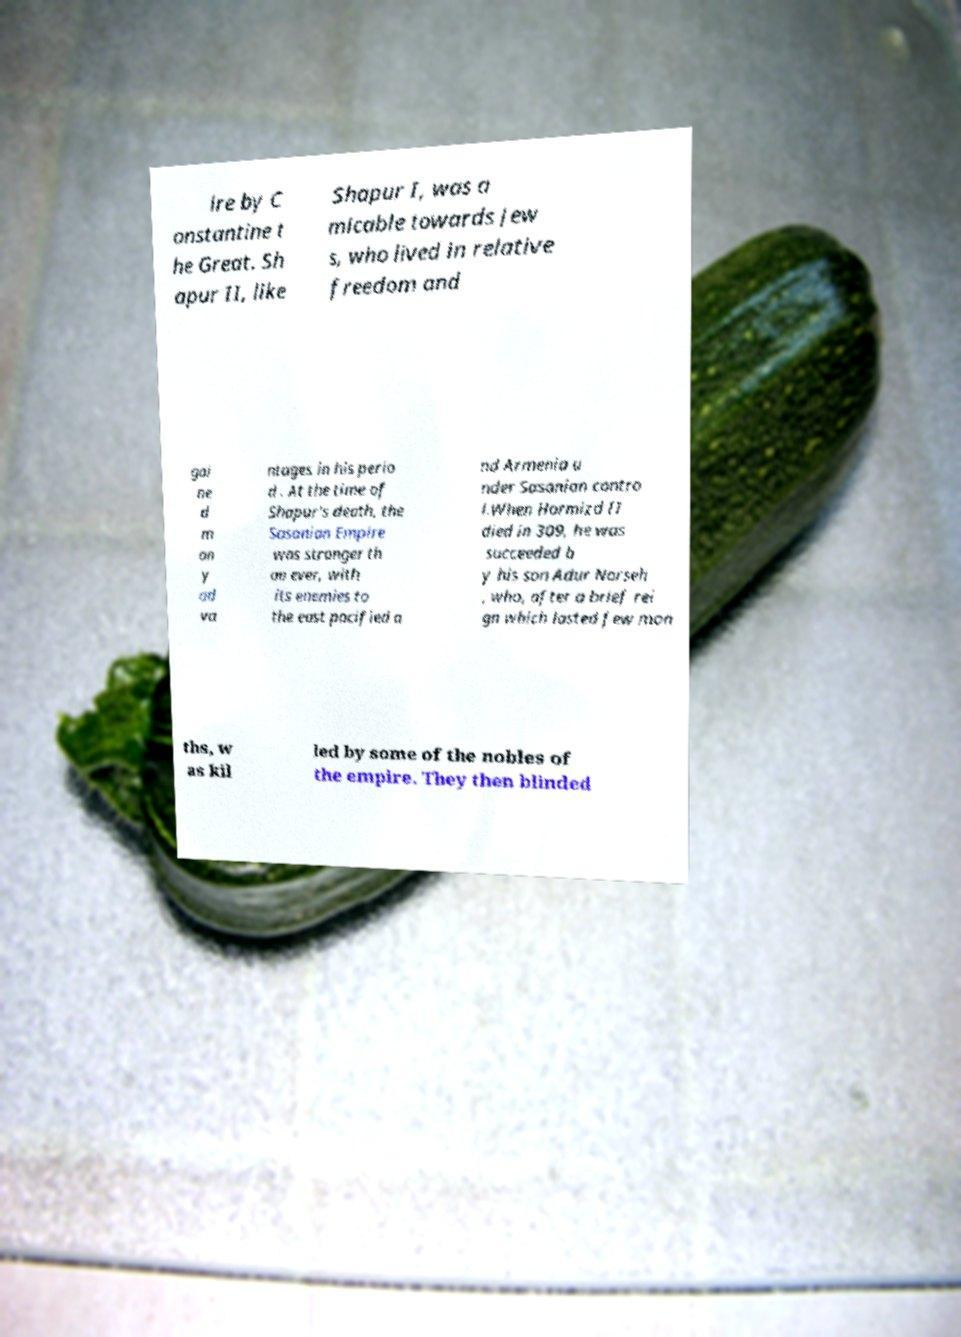Could you assist in decoding the text presented in this image and type it out clearly? ire by C onstantine t he Great. Sh apur II, like Shapur I, was a micable towards Jew s, who lived in relative freedom and gai ne d m an y ad va ntages in his perio d . At the time of Shapur's death, the Sasanian Empire was stronger th an ever, with its enemies to the east pacified a nd Armenia u nder Sasanian contro l.When Hormizd II died in 309, he was succeeded b y his son Adur Narseh , who, after a brief rei gn which lasted few mon ths, w as kil led by some of the nobles of the empire. They then blinded 